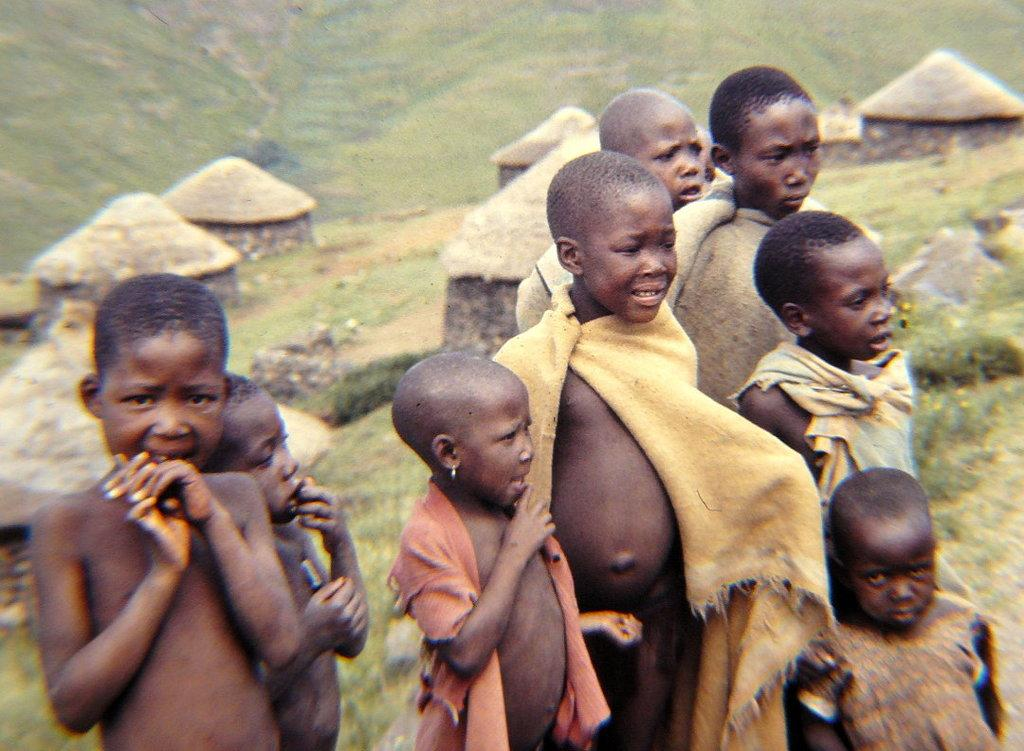Who are the subjects in the image? There are tribal children in the picture. What are the children doing in the image? The children are standing with some clothes. What can be seen in the background of the image? There are grass hills and huts on the grass hills in the background. How many clocks can be seen hanging on the huts in the image? There are no clocks visible in the image; the image only shows tribal children, grass hills, and huts. 